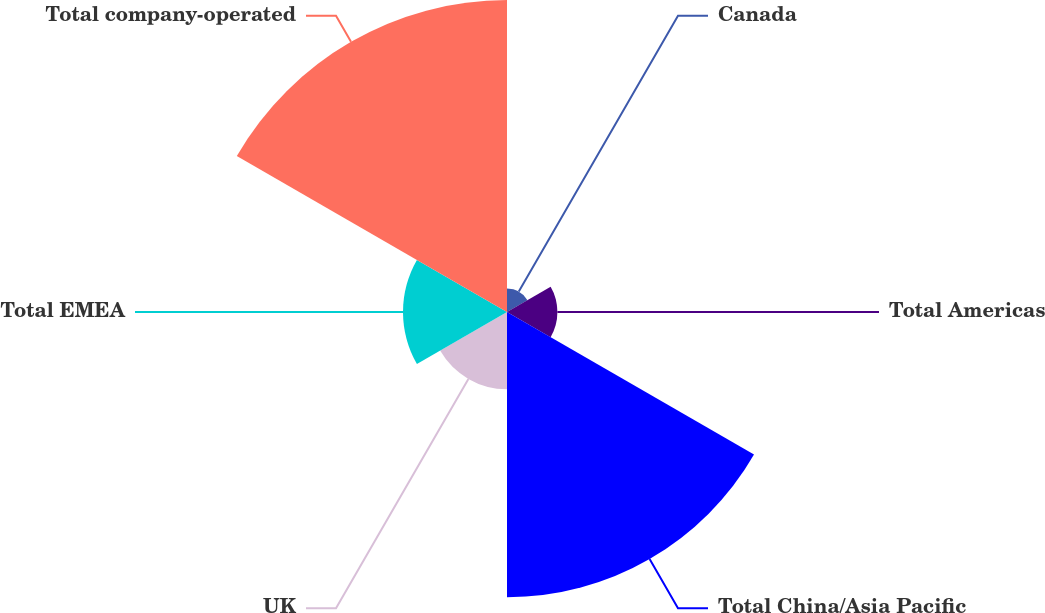Convert chart. <chart><loc_0><loc_0><loc_500><loc_500><pie_chart><fcel>Canada<fcel>Total Americas<fcel>Total China/Asia Pacific<fcel>UK<fcel>Total EMEA<fcel>Total company-operated<nl><fcel>2.77%<fcel>5.91%<fcel>33.46%<fcel>9.06%<fcel>12.2%<fcel>36.6%<nl></chart> 